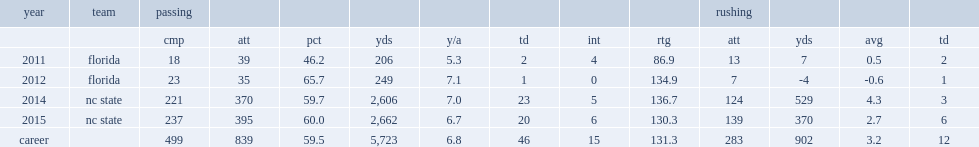In 2014, how many yards did jacoby brissett pass with 23 touchdowns and five interceptions? 2606.0. 